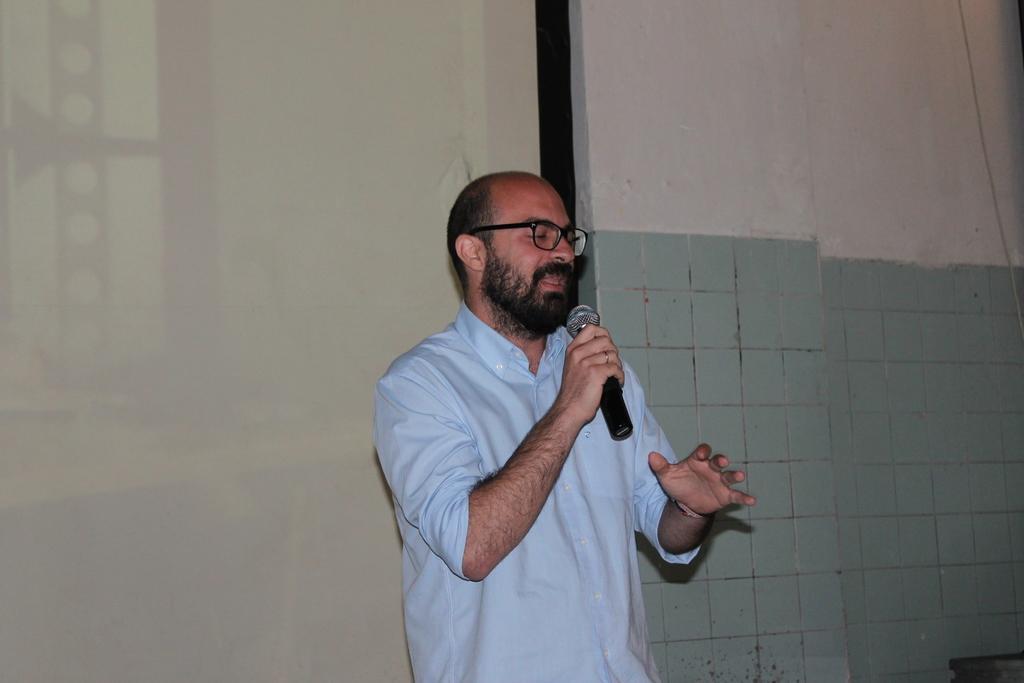Please provide a concise description of this image. In this picture we can see a man wore spectacles, holding a mic with his hand and in the background we can see the wall. 